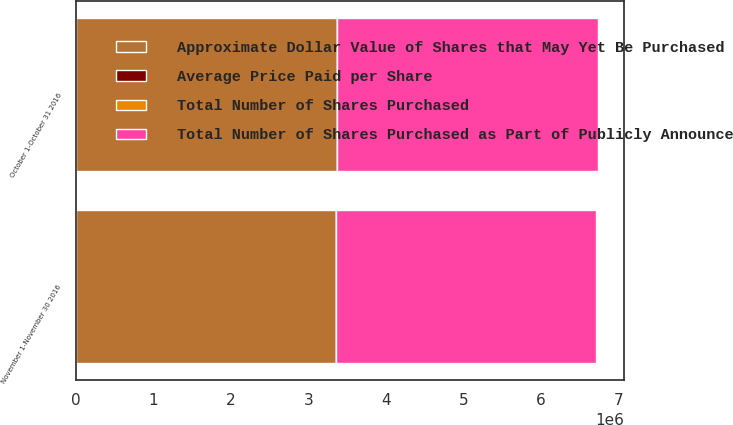Convert chart to OTSL. <chart><loc_0><loc_0><loc_500><loc_500><stacked_bar_chart><ecel><fcel>October 1-October 31 2016<fcel>November 1-November 30 2016<nl><fcel>Total Number of Shares Purchased as Part of Publicly Announced Plans or Programs 1<fcel>3.36702e+06<fcel>3.35163e+06<nl><fcel>Average Price Paid per Share<fcel>63.07<fcel>60.85<nl><fcel>Approximate Dollar Value of Shares that May Yet Be Purchased Under the Plans or Programs in millions<fcel>3.36702e+06<fcel>3.35163e+06<nl><fcel>Total Number of Shares Purchased<fcel>881<fcel>677.1<nl></chart> 